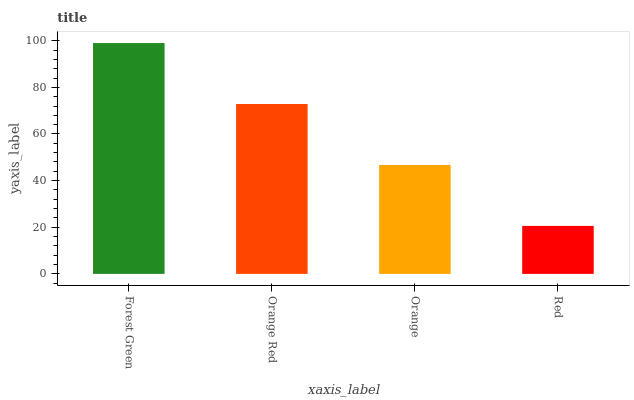Is Orange Red the minimum?
Answer yes or no. No. Is Orange Red the maximum?
Answer yes or no. No. Is Forest Green greater than Orange Red?
Answer yes or no. Yes. Is Orange Red less than Forest Green?
Answer yes or no. Yes. Is Orange Red greater than Forest Green?
Answer yes or no. No. Is Forest Green less than Orange Red?
Answer yes or no. No. Is Orange Red the high median?
Answer yes or no. Yes. Is Orange the low median?
Answer yes or no. Yes. Is Orange the high median?
Answer yes or no. No. Is Orange Red the low median?
Answer yes or no. No. 